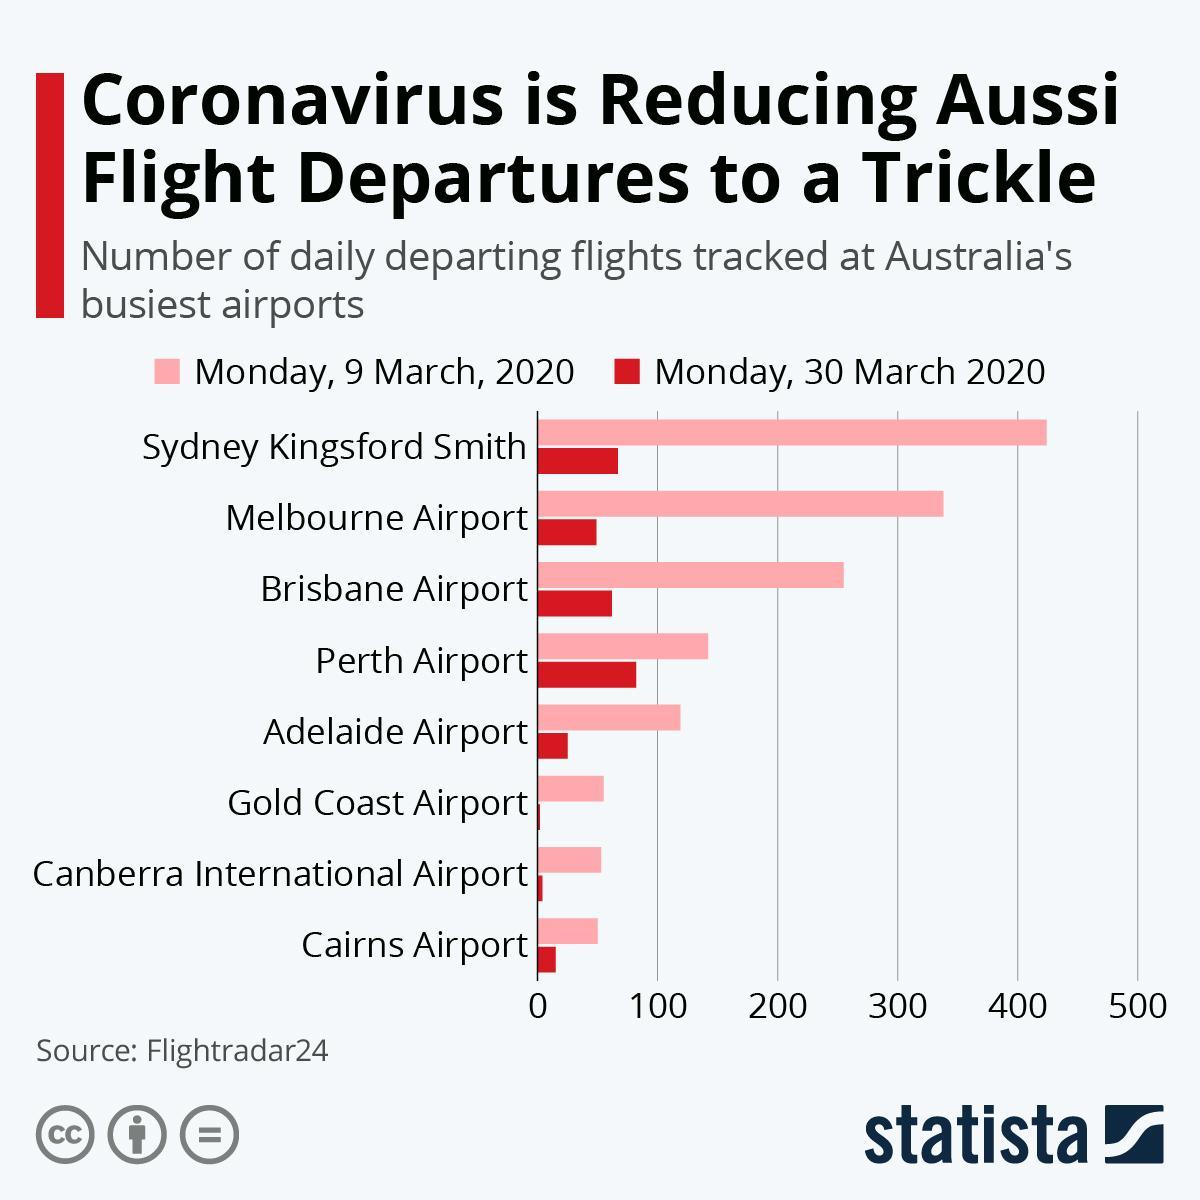From which airport did the second highest number of flights depart on 9 March 2020?
Answer the question with a short phrase. Melbourne Airport Which airport saw highest number of departures on 30th March 2020? Perth Airport Which airport saw second lowest number of departures on 30th March 2020? Canberra International Airport From which airport did the third highest number of flights depart on 9 March 2020? Brisbane Airport 